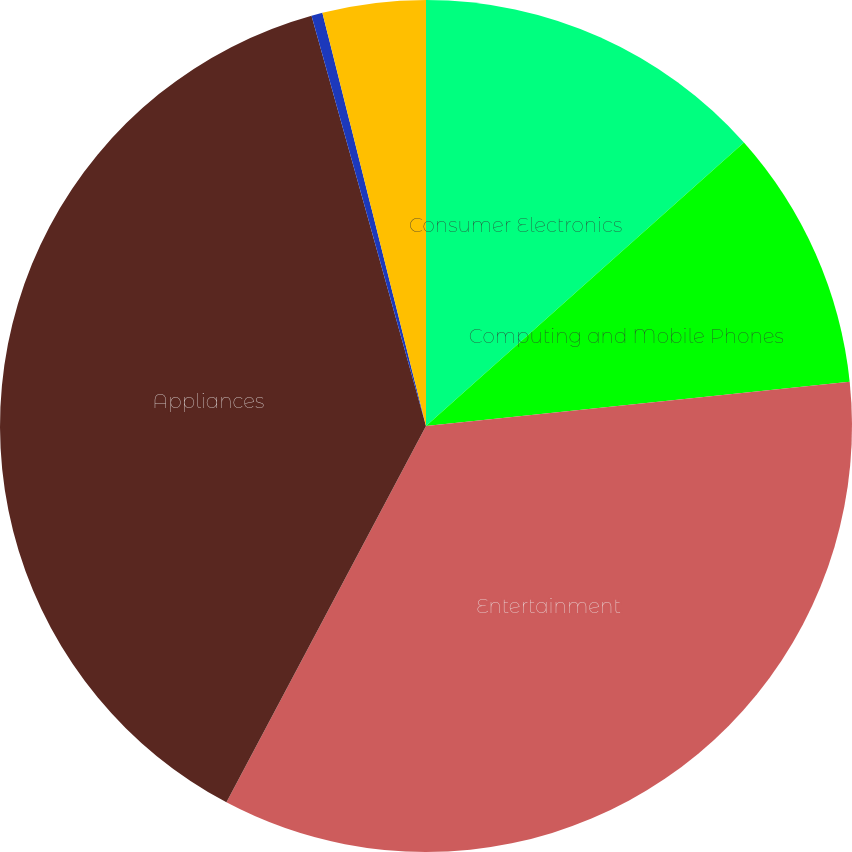Convert chart. <chart><loc_0><loc_0><loc_500><loc_500><pie_chart><fcel>Consumer Electronics<fcel>Computing and Mobile Phones<fcel>Entertainment<fcel>Appliances<fcel>Services<fcel>Total<nl><fcel>13.41%<fcel>9.93%<fcel>34.42%<fcel>37.91%<fcel>0.42%<fcel>3.91%<nl></chart> 